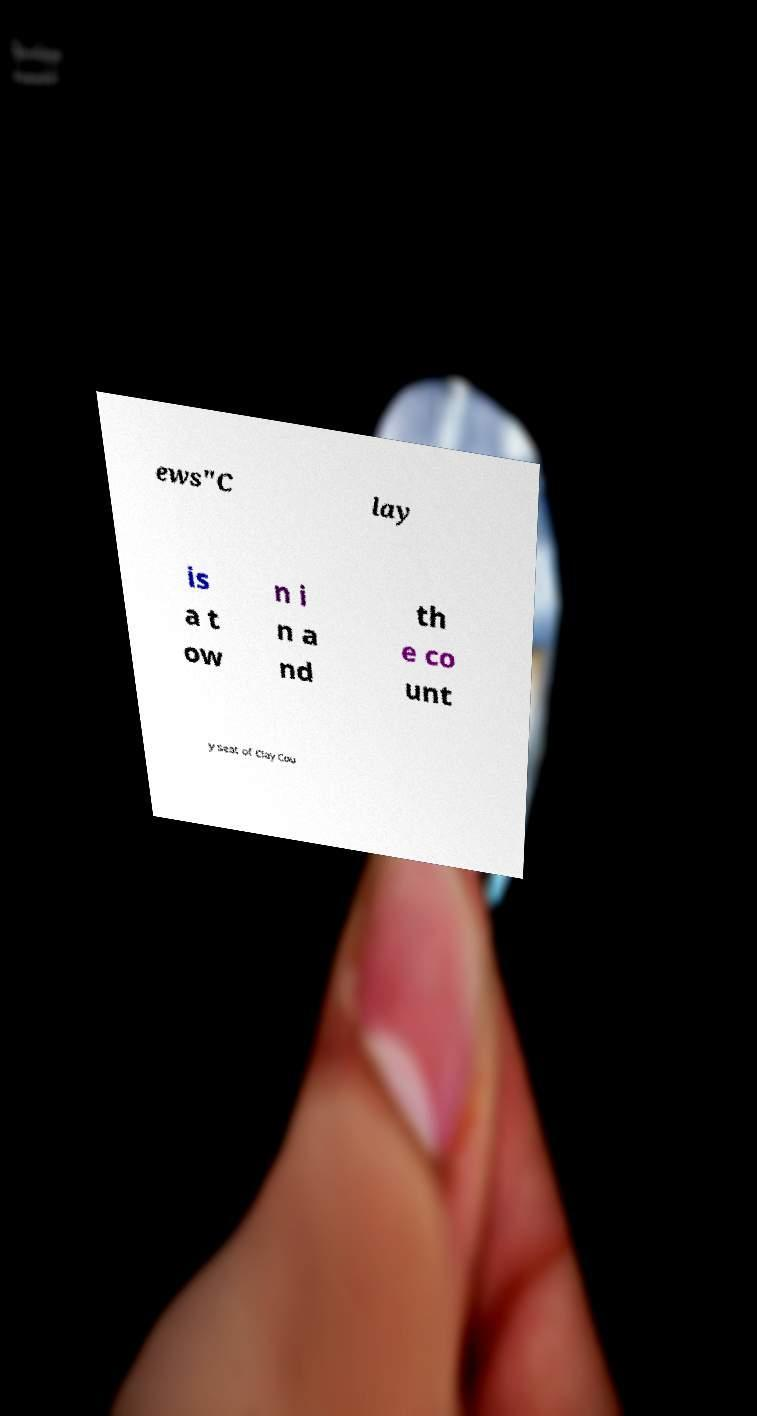I need the written content from this picture converted into text. Can you do that? ews"C lay is a t ow n i n a nd th e co unt y seat of Clay Cou 